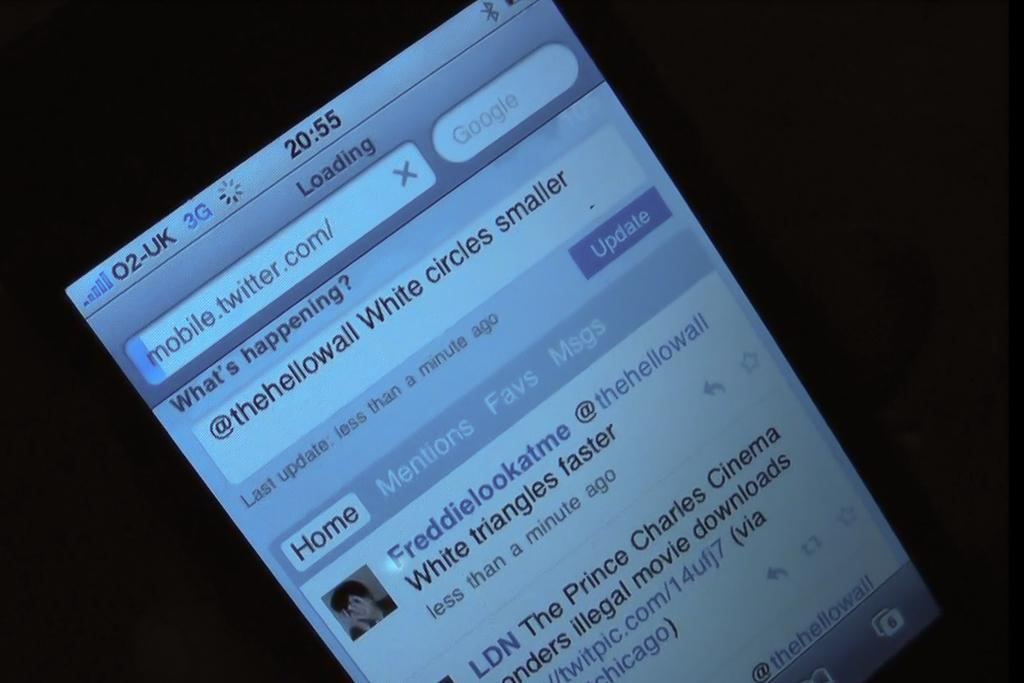<image>
Provide a brief description of the given image. A screen of a phone displays a Twitter page open, where someone is tweeting "White circles smaller" 